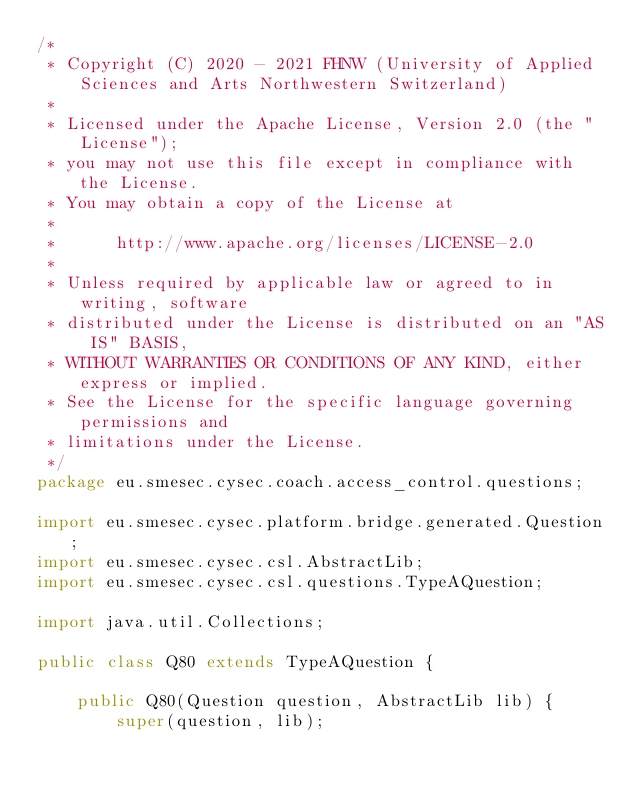Convert code to text. <code><loc_0><loc_0><loc_500><loc_500><_Java_>/*
 * Copyright (C) 2020 - 2021 FHNW (University of Applied Sciences and Arts Northwestern Switzerland)
 *
 * Licensed under the Apache License, Version 2.0 (the "License");
 * you may not use this file except in compliance with the License.
 * You may obtain a copy of the License at
 *
 *      http://www.apache.org/licenses/LICENSE-2.0
 *
 * Unless required by applicable law or agreed to in writing, software
 * distributed under the License is distributed on an "AS IS" BASIS,
 * WITHOUT WARRANTIES OR CONDITIONS OF ANY KIND, either express or implied.
 * See the License for the specific language governing permissions and
 * limitations under the License.
 */
package eu.smesec.cysec.coach.access_control.questions;

import eu.smesec.cysec.platform.bridge.generated.Question;
import eu.smesec.cysec.csl.AbstractLib;
import eu.smesec.cysec.csl.questions.TypeAQuestion;

import java.util.Collections;

public class Q80 extends TypeAQuestion {

    public Q80(Question question, AbstractLib lib) {
        super(question, lib);
</code> 